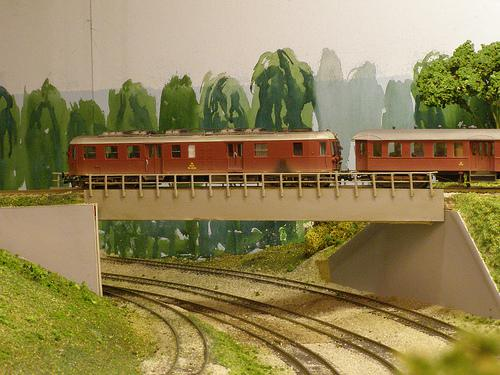Question: who is in the photo?
Choices:
A. A man.
B. Nobody.
C. A family.
D. A girl.
Answer with the letter. Answer: B Question: when was the photo taken?
Choices:
A. During the day.
B. At night.
C. On the night of the full moon.
D. On my last hunting trip.
Answer with the letter. Answer: A Question: what is under the bridge?
Choices:
A. A creek.
B. A river.
C. A highway.
D. Train tracks.
Answer with the letter. Answer: D 